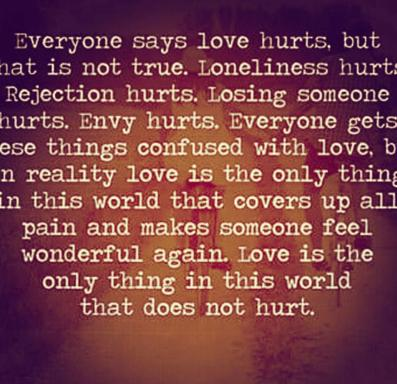What impact does the color choice have on the message of the image? The use of purple and brown in the background of the image likely serves multiple purposes. Purple can represent nobility, power, and ambition but also magic and mystery, perhaps hinting at the complex and profound nature of love. Brown earthy tones might ground the message, emphasizing stability and reliability, which are foundational aspects of true love. 